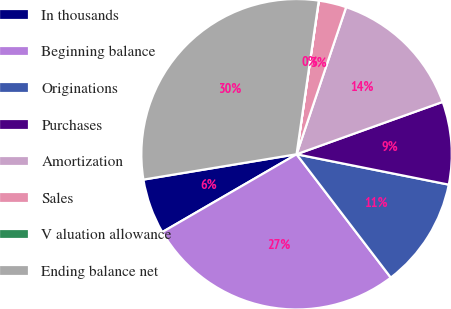Convert chart to OTSL. <chart><loc_0><loc_0><loc_500><loc_500><pie_chart><fcel>In thousands<fcel>Beginning balance<fcel>Originations<fcel>Purchases<fcel>Amortization<fcel>Sales<fcel>V aluation allowance<fcel>Ending balance net<nl><fcel>5.75%<fcel>27.02%<fcel>11.48%<fcel>8.61%<fcel>14.35%<fcel>2.88%<fcel>0.01%<fcel>29.89%<nl></chart> 